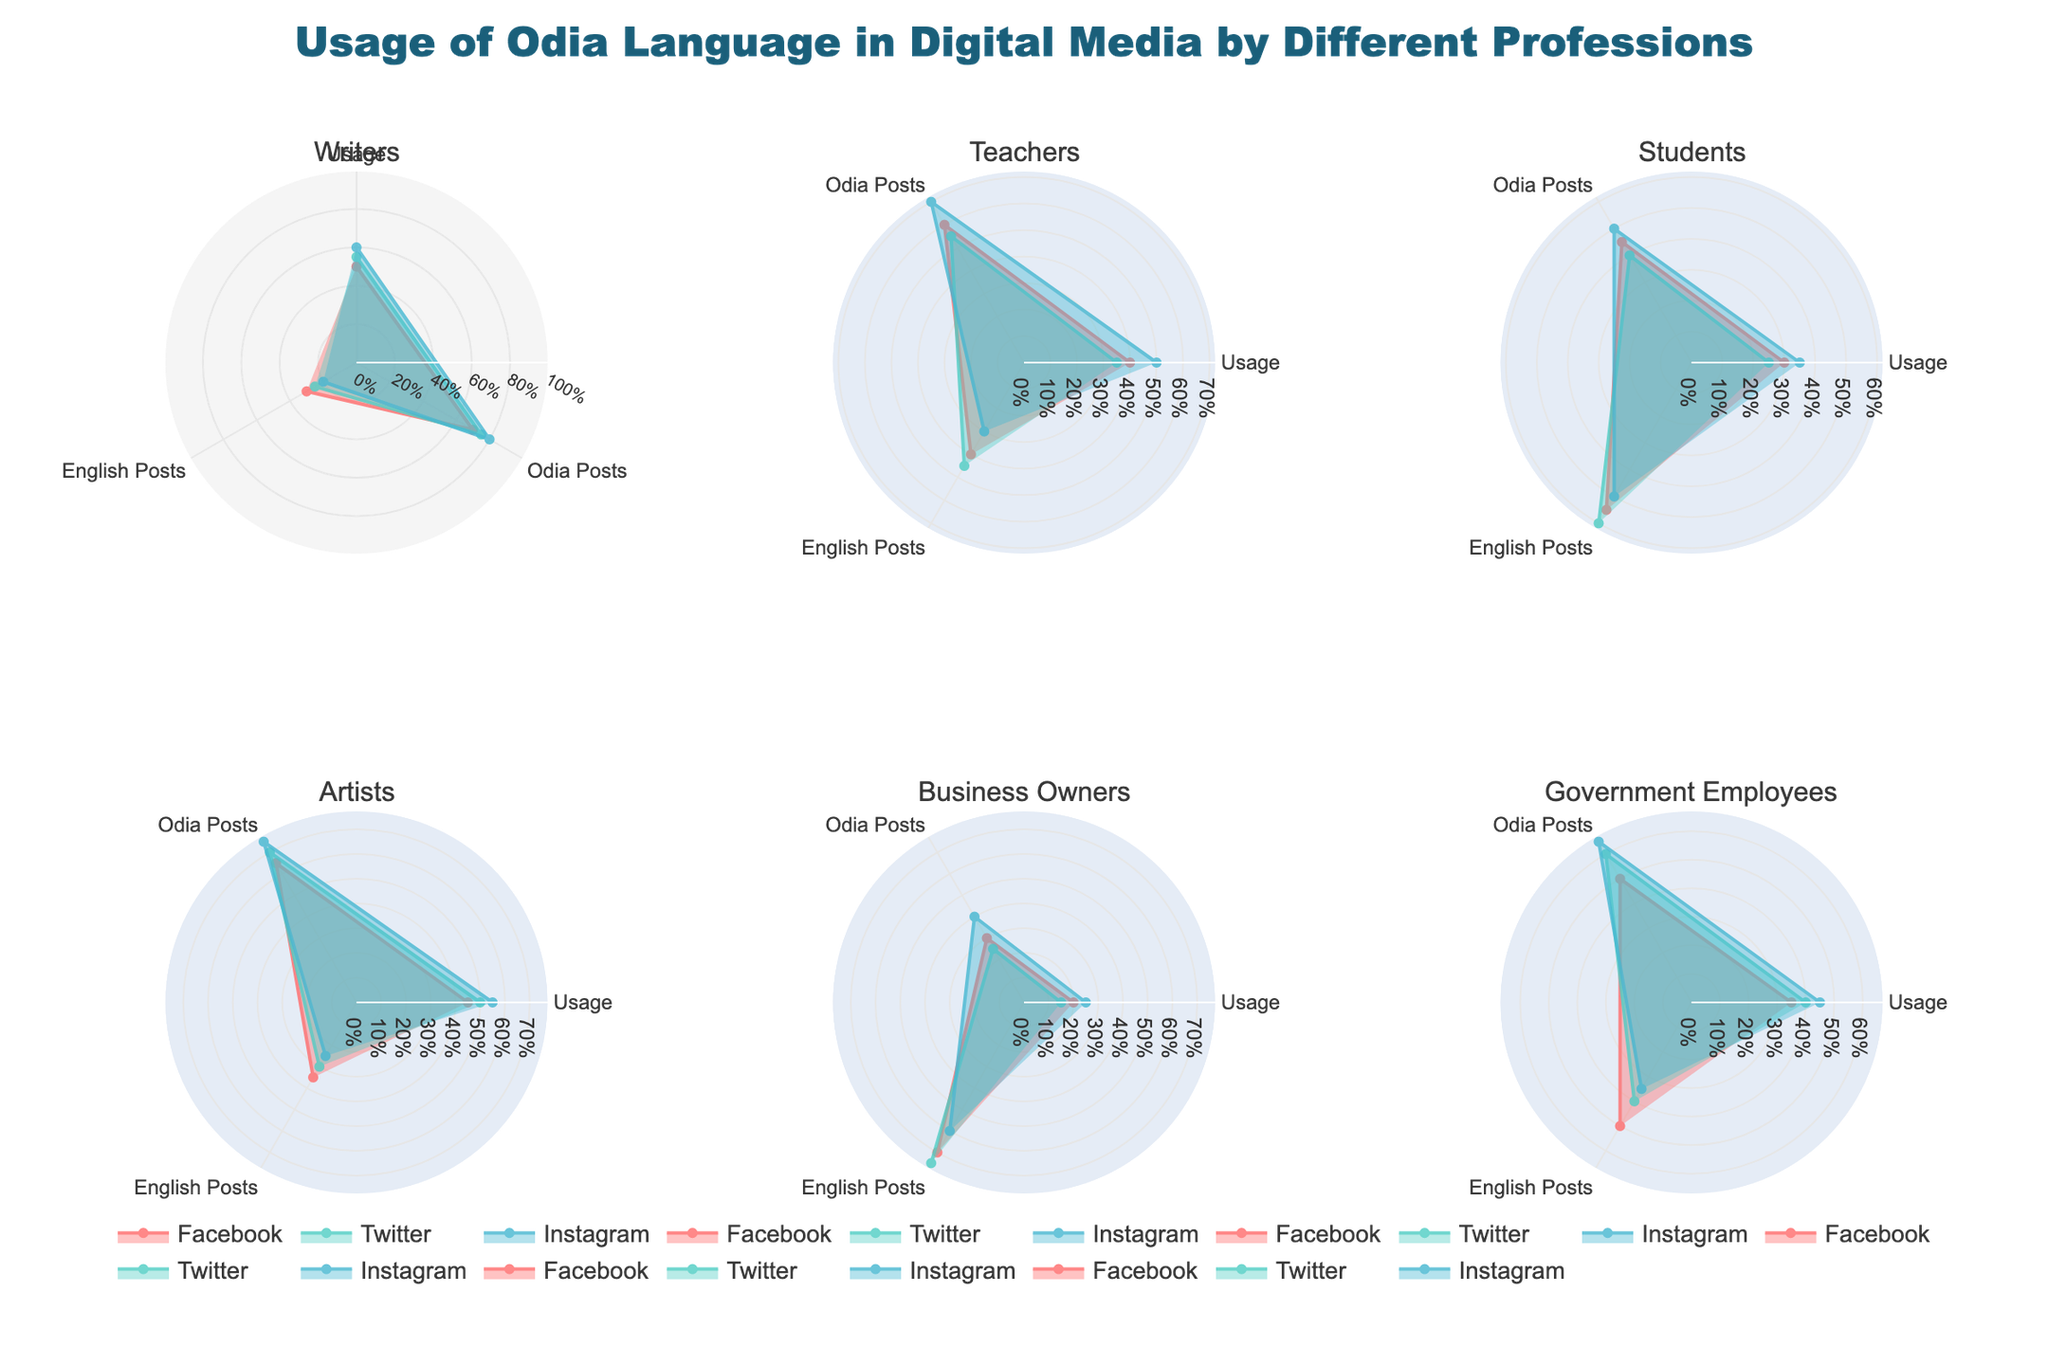What is the most used social media platform by Writers for Odia posts? By looking at the subplot for Writers, we compare the values for Odia Posts across the platforms. Instagram has the highest value for Odia Posts among Facebook, Twitter, and Instagram.
Answer: Instagram Which profession shows the highest percentage usage of Odia language on Twitter? Compare the 'Percentage Usage' for each profession on Twitter. Writers display the highest percentage usage with 55%.
Answer: Writers How do Teachers compare to Students in terms of the percentage usage of Odia on Instagram? Examine the plot for Teachers and Students for Instagram. Teachers have a 'Percentage Usage' of 50%, whereas Students have 35%. Teachers have a higher percentage usage.
Answer: Teachers Which profession has the least English posts on Facebook? Observing the subplot for Facebook across all professions, Writers have the lowest number of English posts at 30.
Answer: Writers What is the average percentage usage of Odia language on Facebook among all professions? Calculate the average by summing the 'Percentage Usage' for each profession on Facebook and dividing by the total number of professions: (50 + 40 + 30 + 45 + 20 + 35) / 6 = 36.67.
Answer: 36.67 Compared to Government Employees, which profession uses Odia more on Instagram? Observe the 'Percentage Usage' for Government Employees on Instagram (45%) and compare with other professions. Writers (60%) and Artists (55%) both have higher values.
Answer: Writers, Artists Does any profession have equal usage of Odia and English posts on any platform? By checking the 'Odia Posts' and 'English Posts' values across all subplots, none of the professions have equal usage of Odia and English posts on any platform.
Answer: No Rank the professions based on their Odia posts on Twitter, from highest to lowest. Compare the 'Odia Posts' for each profession on Twitter: Writers (75), Artists (70), Government Employees (60), Teachers (55), Students (40), Business Owners (25).
Answer: Writers > Artists > Government Employees > Teachers > Students > Business Owners Which social media platform shows the highest disparity between Odia and English posts for Business Owners? For Business Owners, compare the difference between Odia and English posts across platforms. Facebook has the highest disparity with 30 Odia posts and 70 English posts, resulting in a difference of 40.
Answer: Facebook 